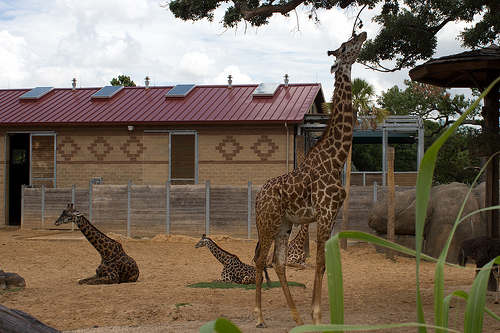Please provide the bounding box coordinate of the region this sentence describes: a giraffe lying in the dirt. The bounding box coordinates for the region describing a giraffe lying in the dirt are [0.07, 0.56, 0.33, 0.77]. 